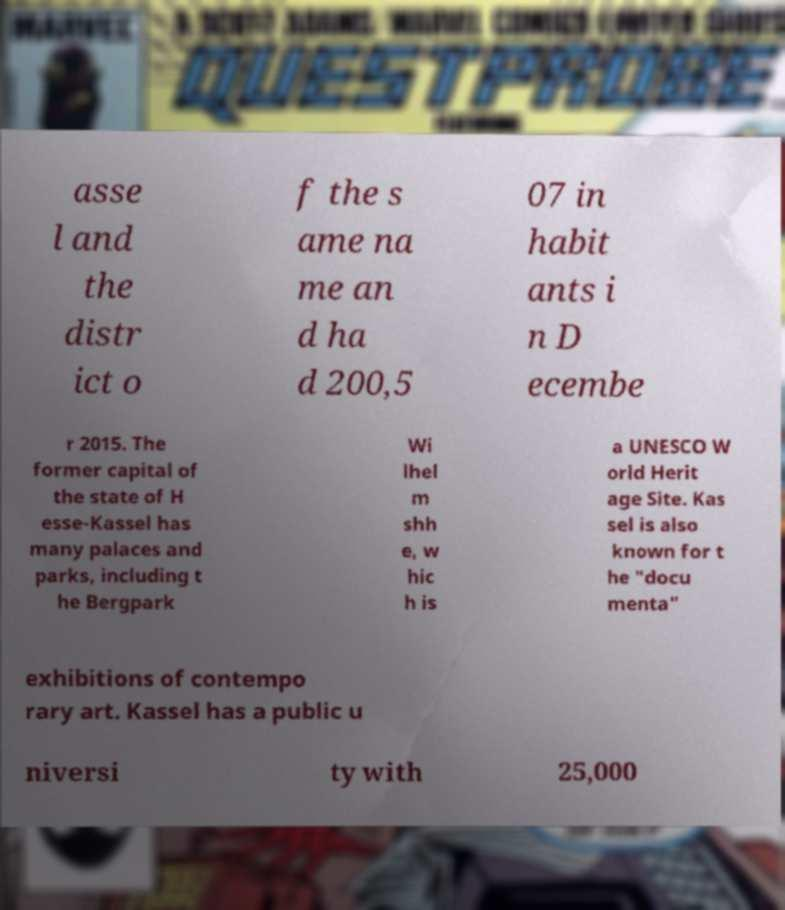There's text embedded in this image that I need extracted. Can you transcribe it verbatim? asse l and the distr ict o f the s ame na me an d ha d 200,5 07 in habit ants i n D ecembe r 2015. The former capital of the state of H esse-Kassel has many palaces and parks, including t he Bergpark Wi lhel m shh e, w hic h is a UNESCO W orld Herit age Site. Kas sel is also known for t he "docu menta" exhibitions of contempo rary art. Kassel has a public u niversi ty with 25,000 